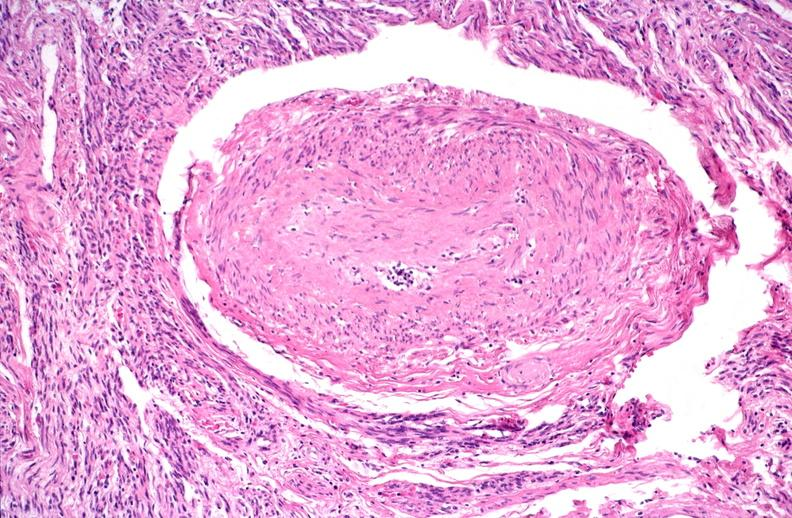what does this image show?
Answer the question using a single word or phrase. Kidney 